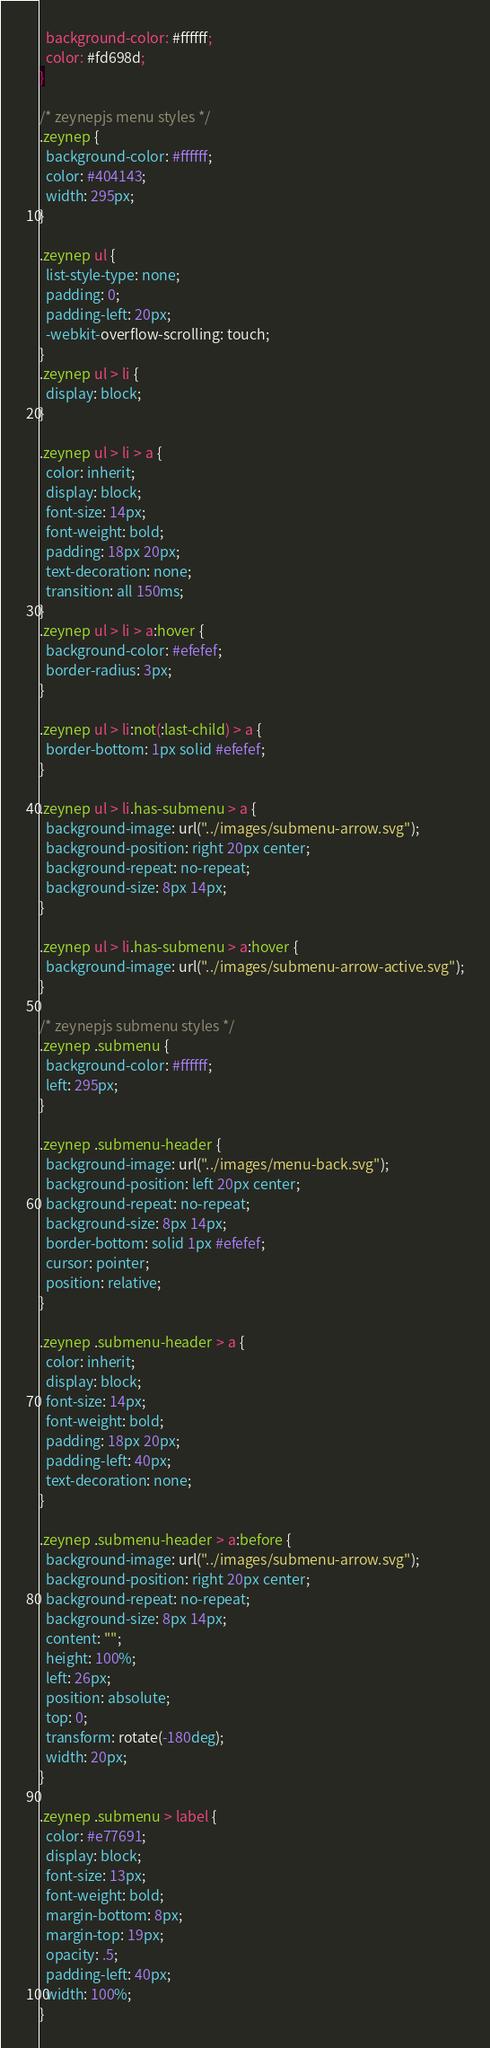<code> <loc_0><loc_0><loc_500><loc_500><_CSS_>  background-color: #ffffff;
  color: #fd698d;
}

/* zeynepjs menu styles */
.zeynep {
  background-color: #ffffff;
  color: #404143;
  width: 295px;
}

.zeynep ul {
  list-style-type: none;
  padding: 0;
  padding-left: 20px;
  -webkit-overflow-scrolling: touch;
}
.zeynep ul > li {
  display: block;
}

.zeynep ul > li > a {
  color: inherit;
  display: block;
  font-size: 14px;
  font-weight: bold;
  padding: 18px 20px;
  text-decoration: none;
  transition: all 150ms;
}
.zeynep ul > li > a:hover {
  background-color: #efefef;
  border-radius: 3px;
}

.zeynep ul > li:not(:last-child) > a {
  border-bottom: 1px solid #efefef;
}

.zeynep ul > li.has-submenu > a {
  background-image: url("../images/submenu-arrow.svg");
  background-position: right 20px center;
  background-repeat: no-repeat;
  background-size: 8px 14px;
}

.zeynep ul > li.has-submenu > a:hover {
  background-image: url("../images/submenu-arrow-active.svg");
}

/* zeynepjs submenu styles */
.zeynep .submenu {
  background-color: #ffffff;
  left: 295px;
}

.zeynep .submenu-header {
  background-image: url("../images/menu-back.svg");
  background-position: left 20px center;
  background-repeat: no-repeat;
  background-size: 8px 14px;
  border-bottom: solid 1px #efefef;
  cursor: pointer;
  position: relative;
}

.zeynep .submenu-header > a {
  color: inherit;
  display: block;
  font-size: 14px;
  font-weight: bold;
  padding: 18px 20px;
  padding-left: 40px;
  text-decoration: none;
}

.zeynep .submenu-header > a:before {
  background-image: url("../images/submenu-arrow.svg");
  background-position: right 20px center;
  background-repeat: no-repeat;
  background-size: 8px 14px;
  content: "";
  height: 100%;
  left: 26px;
  position: absolute;
  top: 0;
  transform: rotate(-180deg);
  width: 20px;
}

.zeynep .submenu > label {
  color: #e77691;
  display: block;
  font-size: 13px;
  font-weight: bold;
  margin-bottom: 8px;
  margin-top: 19px;
  opacity: .5;
  padding-left: 40px;
  width: 100%;
}
</code> 